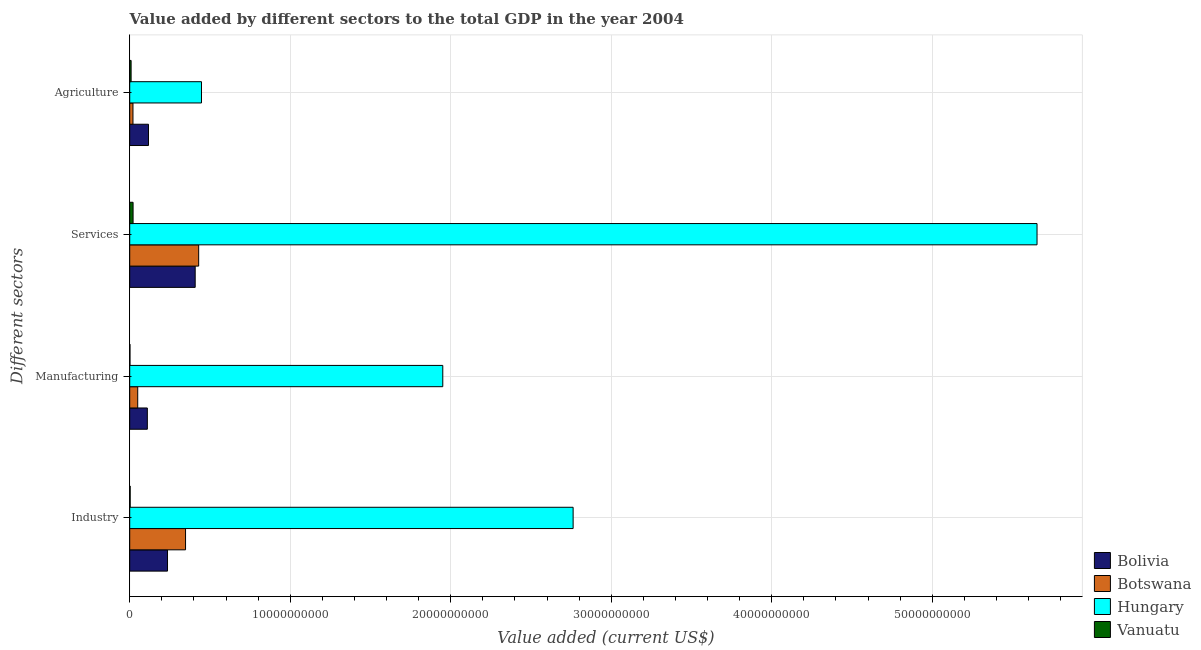How many bars are there on the 1st tick from the bottom?
Give a very brief answer. 4. What is the label of the 4th group of bars from the top?
Make the answer very short. Industry. What is the value added by services sector in Botswana?
Offer a very short reply. 4.30e+09. Across all countries, what is the maximum value added by industrial sector?
Offer a very short reply. 2.76e+1. Across all countries, what is the minimum value added by industrial sector?
Keep it short and to the point. 2.77e+07. In which country was the value added by manufacturing sector maximum?
Make the answer very short. Hungary. In which country was the value added by manufacturing sector minimum?
Offer a terse response. Vanuatu. What is the total value added by services sector in the graph?
Offer a very short reply. 6.51e+1. What is the difference between the value added by industrial sector in Botswana and that in Bolivia?
Give a very brief answer. 1.12e+09. What is the difference between the value added by manufacturing sector in Vanuatu and the value added by services sector in Botswana?
Give a very brief answer. -4.28e+09. What is the average value added by agricultural sector per country?
Your answer should be compact. 1.48e+09. What is the difference between the value added by agricultural sector and value added by services sector in Bolivia?
Your response must be concise. -2.91e+09. What is the ratio of the value added by agricultural sector in Hungary to that in Vanuatu?
Offer a very short reply. 51.9. Is the difference between the value added by agricultural sector in Hungary and Bolivia greater than the difference between the value added by industrial sector in Hungary and Bolivia?
Keep it short and to the point. No. What is the difference between the highest and the second highest value added by industrial sector?
Keep it short and to the point. 2.41e+1. What is the difference between the highest and the lowest value added by agricultural sector?
Provide a succinct answer. 4.38e+09. Is it the case that in every country, the sum of the value added by services sector and value added by agricultural sector is greater than the sum of value added by industrial sector and value added by manufacturing sector?
Provide a succinct answer. No. What does the 1st bar from the top in Industry represents?
Ensure brevity in your answer.  Vanuatu. What does the 4th bar from the bottom in Services represents?
Provide a short and direct response. Vanuatu. Are all the bars in the graph horizontal?
Provide a short and direct response. Yes. Are the values on the major ticks of X-axis written in scientific E-notation?
Your answer should be compact. No. Does the graph contain any zero values?
Your answer should be compact. No. Does the graph contain grids?
Offer a very short reply. Yes. How are the legend labels stacked?
Offer a very short reply. Vertical. What is the title of the graph?
Ensure brevity in your answer.  Value added by different sectors to the total GDP in the year 2004. What is the label or title of the X-axis?
Provide a short and direct response. Value added (current US$). What is the label or title of the Y-axis?
Offer a very short reply. Different sectors. What is the Value added (current US$) in Bolivia in Industry?
Your answer should be compact. 2.35e+09. What is the Value added (current US$) of Botswana in Industry?
Provide a succinct answer. 3.48e+09. What is the Value added (current US$) in Hungary in Industry?
Keep it short and to the point. 2.76e+1. What is the Value added (current US$) of Vanuatu in Industry?
Provide a succinct answer. 2.77e+07. What is the Value added (current US$) in Bolivia in Manufacturing?
Ensure brevity in your answer.  1.10e+09. What is the Value added (current US$) in Botswana in Manufacturing?
Give a very brief answer. 4.98e+08. What is the Value added (current US$) in Hungary in Manufacturing?
Keep it short and to the point. 1.95e+1. What is the Value added (current US$) of Vanuatu in Manufacturing?
Give a very brief answer. 1.47e+07. What is the Value added (current US$) of Bolivia in Services?
Provide a short and direct response. 4.08e+09. What is the Value added (current US$) in Botswana in Services?
Your answer should be very brief. 4.30e+09. What is the Value added (current US$) in Hungary in Services?
Provide a short and direct response. 5.65e+1. What is the Value added (current US$) of Vanuatu in Services?
Offer a terse response. 2.09e+08. What is the Value added (current US$) in Bolivia in Agriculture?
Give a very brief answer. 1.17e+09. What is the Value added (current US$) of Botswana in Agriculture?
Keep it short and to the point. 2.02e+08. What is the Value added (current US$) in Hungary in Agriculture?
Provide a short and direct response. 4.47e+09. What is the Value added (current US$) of Vanuatu in Agriculture?
Provide a succinct answer. 8.61e+07. Across all Different sectors, what is the maximum Value added (current US$) in Bolivia?
Your answer should be compact. 4.08e+09. Across all Different sectors, what is the maximum Value added (current US$) of Botswana?
Offer a very short reply. 4.30e+09. Across all Different sectors, what is the maximum Value added (current US$) of Hungary?
Provide a succinct answer. 5.65e+1. Across all Different sectors, what is the maximum Value added (current US$) in Vanuatu?
Provide a short and direct response. 2.09e+08. Across all Different sectors, what is the minimum Value added (current US$) in Bolivia?
Offer a terse response. 1.10e+09. Across all Different sectors, what is the minimum Value added (current US$) in Botswana?
Provide a succinct answer. 2.02e+08. Across all Different sectors, what is the minimum Value added (current US$) in Hungary?
Provide a succinct answer. 4.47e+09. Across all Different sectors, what is the minimum Value added (current US$) in Vanuatu?
Give a very brief answer. 1.47e+07. What is the total Value added (current US$) in Bolivia in the graph?
Make the answer very short. 8.70e+09. What is the total Value added (current US$) of Botswana in the graph?
Ensure brevity in your answer.  8.47e+09. What is the total Value added (current US$) of Hungary in the graph?
Provide a succinct answer. 1.08e+11. What is the total Value added (current US$) of Vanuatu in the graph?
Keep it short and to the point. 3.38e+08. What is the difference between the Value added (current US$) of Bolivia in Industry and that in Manufacturing?
Provide a short and direct response. 1.26e+09. What is the difference between the Value added (current US$) of Botswana in Industry and that in Manufacturing?
Provide a succinct answer. 2.98e+09. What is the difference between the Value added (current US$) of Hungary in Industry and that in Manufacturing?
Offer a very short reply. 8.12e+09. What is the difference between the Value added (current US$) of Vanuatu in Industry and that in Manufacturing?
Offer a very short reply. 1.30e+07. What is the difference between the Value added (current US$) of Bolivia in Industry and that in Services?
Your response must be concise. -1.72e+09. What is the difference between the Value added (current US$) in Botswana in Industry and that in Services?
Provide a short and direct response. -8.18e+08. What is the difference between the Value added (current US$) of Hungary in Industry and that in Services?
Provide a succinct answer. -2.89e+1. What is the difference between the Value added (current US$) in Vanuatu in Industry and that in Services?
Give a very brief answer. -1.82e+08. What is the difference between the Value added (current US$) of Bolivia in Industry and that in Agriculture?
Offer a terse response. 1.19e+09. What is the difference between the Value added (current US$) in Botswana in Industry and that in Agriculture?
Give a very brief answer. 3.28e+09. What is the difference between the Value added (current US$) in Hungary in Industry and that in Agriculture?
Keep it short and to the point. 2.32e+1. What is the difference between the Value added (current US$) of Vanuatu in Industry and that in Agriculture?
Ensure brevity in your answer.  -5.84e+07. What is the difference between the Value added (current US$) in Bolivia in Manufacturing and that in Services?
Give a very brief answer. -2.98e+09. What is the difference between the Value added (current US$) of Botswana in Manufacturing and that in Services?
Offer a terse response. -3.80e+09. What is the difference between the Value added (current US$) of Hungary in Manufacturing and that in Services?
Make the answer very short. -3.70e+1. What is the difference between the Value added (current US$) in Vanuatu in Manufacturing and that in Services?
Your answer should be compact. -1.95e+08. What is the difference between the Value added (current US$) in Bolivia in Manufacturing and that in Agriculture?
Provide a short and direct response. -7.15e+07. What is the difference between the Value added (current US$) of Botswana in Manufacturing and that in Agriculture?
Your response must be concise. 2.95e+08. What is the difference between the Value added (current US$) in Hungary in Manufacturing and that in Agriculture?
Offer a terse response. 1.50e+1. What is the difference between the Value added (current US$) of Vanuatu in Manufacturing and that in Agriculture?
Your answer should be very brief. -7.14e+07. What is the difference between the Value added (current US$) in Bolivia in Services and that in Agriculture?
Your response must be concise. 2.91e+09. What is the difference between the Value added (current US$) of Botswana in Services and that in Agriculture?
Provide a short and direct response. 4.09e+09. What is the difference between the Value added (current US$) of Hungary in Services and that in Agriculture?
Your response must be concise. 5.21e+1. What is the difference between the Value added (current US$) of Vanuatu in Services and that in Agriculture?
Ensure brevity in your answer.  1.23e+08. What is the difference between the Value added (current US$) in Bolivia in Industry and the Value added (current US$) in Botswana in Manufacturing?
Your answer should be compact. 1.86e+09. What is the difference between the Value added (current US$) in Bolivia in Industry and the Value added (current US$) in Hungary in Manufacturing?
Make the answer very short. -1.71e+1. What is the difference between the Value added (current US$) in Bolivia in Industry and the Value added (current US$) in Vanuatu in Manufacturing?
Ensure brevity in your answer.  2.34e+09. What is the difference between the Value added (current US$) of Botswana in Industry and the Value added (current US$) of Hungary in Manufacturing?
Offer a very short reply. -1.60e+1. What is the difference between the Value added (current US$) in Botswana in Industry and the Value added (current US$) in Vanuatu in Manufacturing?
Ensure brevity in your answer.  3.46e+09. What is the difference between the Value added (current US$) of Hungary in Industry and the Value added (current US$) of Vanuatu in Manufacturing?
Your answer should be very brief. 2.76e+1. What is the difference between the Value added (current US$) in Bolivia in Industry and the Value added (current US$) in Botswana in Services?
Offer a very short reply. -1.94e+09. What is the difference between the Value added (current US$) of Bolivia in Industry and the Value added (current US$) of Hungary in Services?
Make the answer very short. -5.42e+1. What is the difference between the Value added (current US$) in Bolivia in Industry and the Value added (current US$) in Vanuatu in Services?
Your response must be concise. 2.15e+09. What is the difference between the Value added (current US$) in Botswana in Industry and the Value added (current US$) in Hungary in Services?
Your answer should be compact. -5.30e+1. What is the difference between the Value added (current US$) of Botswana in Industry and the Value added (current US$) of Vanuatu in Services?
Provide a succinct answer. 3.27e+09. What is the difference between the Value added (current US$) in Hungary in Industry and the Value added (current US$) in Vanuatu in Services?
Your answer should be very brief. 2.74e+1. What is the difference between the Value added (current US$) in Bolivia in Industry and the Value added (current US$) in Botswana in Agriculture?
Make the answer very short. 2.15e+09. What is the difference between the Value added (current US$) in Bolivia in Industry and the Value added (current US$) in Hungary in Agriculture?
Give a very brief answer. -2.12e+09. What is the difference between the Value added (current US$) in Bolivia in Industry and the Value added (current US$) in Vanuatu in Agriculture?
Give a very brief answer. 2.27e+09. What is the difference between the Value added (current US$) of Botswana in Industry and the Value added (current US$) of Hungary in Agriculture?
Provide a succinct answer. -9.93e+08. What is the difference between the Value added (current US$) of Botswana in Industry and the Value added (current US$) of Vanuatu in Agriculture?
Provide a short and direct response. 3.39e+09. What is the difference between the Value added (current US$) of Hungary in Industry and the Value added (current US$) of Vanuatu in Agriculture?
Ensure brevity in your answer.  2.75e+1. What is the difference between the Value added (current US$) in Bolivia in Manufacturing and the Value added (current US$) in Botswana in Services?
Make the answer very short. -3.20e+09. What is the difference between the Value added (current US$) of Bolivia in Manufacturing and the Value added (current US$) of Hungary in Services?
Make the answer very short. -5.54e+1. What is the difference between the Value added (current US$) of Bolivia in Manufacturing and the Value added (current US$) of Vanuatu in Services?
Give a very brief answer. 8.88e+08. What is the difference between the Value added (current US$) of Botswana in Manufacturing and the Value added (current US$) of Hungary in Services?
Make the answer very short. -5.60e+1. What is the difference between the Value added (current US$) of Botswana in Manufacturing and the Value added (current US$) of Vanuatu in Services?
Your answer should be compact. 2.88e+08. What is the difference between the Value added (current US$) in Hungary in Manufacturing and the Value added (current US$) in Vanuatu in Services?
Your answer should be compact. 1.93e+1. What is the difference between the Value added (current US$) of Bolivia in Manufacturing and the Value added (current US$) of Botswana in Agriculture?
Give a very brief answer. 8.95e+08. What is the difference between the Value added (current US$) of Bolivia in Manufacturing and the Value added (current US$) of Hungary in Agriculture?
Make the answer very short. -3.37e+09. What is the difference between the Value added (current US$) in Bolivia in Manufacturing and the Value added (current US$) in Vanuatu in Agriculture?
Make the answer very short. 1.01e+09. What is the difference between the Value added (current US$) in Botswana in Manufacturing and the Value added (current US$) in Hungary in Agriculture?
Give a very brief answer. -3.97e+09. What is the difference between the Value added (current US$) in Botswana in Manufacturing and the Value added (current US$) in Vanuatu in Agriculture?
Offer a terse response. 4.11e+08. What is the difference between the Value added (current US$) of Hungary in Manufacturing and the Value added (current US$) of Vanuatu in Agriculture?
Provide a succinct answer. 1.94e+1. What is the difference between the Value added (current US$) in Bolivia in Services and the Value added (current US$) in Botswana in Agriculture?
Your answer should be very brief. 3.88e+09. What is the difference between the Value added (current US$) in Bolivia in Services and the Value added (current US$) in Hungary in Agriculture?
Your response must be concise. -3.92e+08. What is the difference between the Value added (current US$) of Bolivia in Services and the Value added (current US$) of Vanuatu in Agriculture?
Your response must be concise. 3.99e+09. What is the difference between the Value added (current US$) in Botswana in Services and the Value added (current US$) in Hungary in Agriculture?
Offer a very short reply. -1.75e+08. What is the difference between the Value added (current US$) in Botswana in Services and the Value added (current US$) in Vanuatu in Agriculture?
Provide a short and direct response. 4.21e+09. What is the difference between the Value added (current US$) of Hungary in Services and the Value added (current US$) of Vanuatu in Agriculture?
Your response must be concise. 5.64e+1. What is the average Value added (current US$) in Bolivia per Different sectors?
Keep it short and to the point. 2.17e+09. What is the average Value added (current US$) of Botswana per Different sectors?
Your response must be concise. 2.12e+09. What is the average Value added (current US$) in Hungary per Different sectors?
Offer a terse response. 2.70e+1. What is the average Value added (current US$) of Vanuatu per Different sectors?
Offer a terse response. 8.45e+07. What is the difference between the Value added (current US$) in Bolivia and Value added (current US$) in Botswana in Industry?
Your response must be concise. -1.12e+09. What is the difference between the Value added (current US$) in Bolivia and Value added (current US$) in Hungary in Industry?
Provide a succinct answer. -2.53e+1. What is the difference between the Value added (current US$) of Bolivia and Value added (current US$) of Vanuatu in Industry?
Provide a succinct answer. 2.33e+09. What is the difference between the Value added (current US$) in Botswana and Value added (current US$) in Hungary in Industry?
Make the answer very short. -2.41e+1. What is the difference between the Value added (current US$) of Botswana and Value added (current US$) of Vanuatu in Industry?
Ensure brevity in your answer.  3.45e+09. What is the difference between the Value added (current US$) in Hungary and Value added (current US$) in Vanuatu in Industry?
Your response must be concise. 2.76e+1. What is the difference between the Value added (current US$) in Bolivia and Value added (current US$) in Botswana in Manufacturing?
Your answer should be compact. 6.00e+08. What is the difference between the Value added (current US$) in Bolivia and Value added (current US$) in Hungary in Manufacturing?
Provide a succinct answer. -1.84e+1. What is the difference between the Value added (current US$) in Bolivia and Value added (current US$) in Vanuatu in Manufacturing?
Keep it short and to the point. 1.08e+09. What is the difference between the Value added (current US$) of Botswana and Value added (current US$) of Hungary in Manufacturing?
Your answer should be very brief. -1.90e+1. What is the difference between the Value added (current US$) of Botswana and Value added (current US$) of Vanuatu in Manufacturing?
Your answer should be very brief. 4.83e+08. What is the difference between the Value added (current US$) in Hungary and Value added (current US$) in Vanuatu in Manufacturing?
Provide a succinct answer. 1.95e+1. What is the difference between the Value added (current US$) of Bolivia and Value added (current US$) of Botswana in Services?
Your response must be concise. -2.17e+08. What is the difference between the Value added (current US$) of Bolivia and Value added (current US$) of Hungary in Services?
Your answer should be compact. -5.24e+1. What is the difference between the Value added (current US$) of Bolivia and Value added (current US$) of Vanuatu in Services?
Offer a very short reply. 3.87e+09. What is the difference between the Value added (current US$) in Botswana and Value added (current US$) in Hungary in Services?
Ensure brevity in your answer.  -5.22e+1. What is the difference between the Value added (current US$) in Botswana and Value added (current US$) in Vanuatu in Services?
Ensure brevity in your answer.  4.09e+09. What is the difference between the Value added (current US$) in Hungary and Value added (current US$) in Vanuatu in Services?
Your response must be concise. 5.63e+1. What is the difference between the Value added (current US$) in Bolivia and Value added (current US$) in Botswana in Agriculture?
Make the answer very short. 9.66e+08. What is the difference between the Value added (current US$) in Bolivia and Value added (current US$) in Hungary in Agriculture?
Your answer should be compact. -3.30e+09. What is the difference between the Value added (current US$) of Bolivia and Value added (current US$) of Vanuatu in Agriculture?
Keep it short and to the point. 1.08e+09. What is the difference between the Value added (current US$) of Botswana and Value added (current US$) of Hungary in Agriculture?
Provide a succinct answer. -4.27e+09. What is the difference between the Value added (current US$) of Botswana and Value added (current US$) of Vanuatu in Agriculture?
Provide a short and direct response. 1.16e+08. What is the difference between the Value added (current US$) of Hungary and Value added (current US$) of Vanuatu in Agriculture?
Give a very brief answer. 4.38e+09. What is the ratio of the Value added (current US$) of Bolivia in Industry to that in Manufacturing?
Offer a very short reply. 2.15. What is the ratio of the Value added (current US$) of Botswana in Industry to that in Manufacturing?
Offer a terse response. 6.99. What is the ratio of the Value added (current US$) in Hungary in Industry to that in Manufacturing?
Your answer should be compact. 1.42. What is the ratio of the Value added (current US$) in Vanuatu in Industry to that in Manufacturing?
Ensure brevity in your answer.  1.88. What is the ratio of the Value added (current US$) in Bolivia in Industry to that in Services?
Your response must be concise. 0.58. What is the ratio of the Value added (current US$) of Botswana in Industry to that in Services?
Ensure brevity in your answer.  0.81. What is the ratio of the Value added (current US$) of Hungary in Industry to that in Services?
Provide a succinct answer. 0.49. What is the ratio of the Value added (current US$) of Vanuatu in Industry to that in Services?
Provide a succinct answer. 0.13. What is the ratio of the Value added (current US$) in Bolivia in Industry to that in Agriculture?
Offer a very short reply. 2.01. What is the ratio of the Value added (current US$) in Botswana in Industry to that in Agriculture?
Make the answer very short. 17.18. What is the ratio of the Value added (current US$) in Hungary in Industry to that in Agriculture?
Keep it short and to the point. 6.18. What is the ratio of the Value added (current US$) of Vanuatu in Industry to that in Agriculture?
Offer a very short reply. 0.32. What is the ratio of the Value added (current US$) in Bolivia in Manufacturing to that in Services?
Offer a very short reply. 0.27. What is the ratio of the Value added (current US$) in Botswana in Manufacturing to that in Services?
Provide a succinct answer. 0.12. What is the ratio of the Value added (current US$) in Hungary in Manufacturing to that in Services?
Offer a terse response. 0.34. What is the ratio of the Value added (current US$) in Vanuatu in Manufacturing to that in Services?
Provide a succinct answer. 0.07. What is the ratio of the Value added (current US$) in Bolivia in Manufacturing to that in Agriculture?
Ensure brevity in your answer.  0.94. What is the ratio of the Value added (current US$) of Botswana in Manufacturing to that in Agriculture?
Your answer should be very brief. 2.46. What is the ratio of the Value added (current US$) of Hungary in Manufacturing to that in Agriculture?
Provide a succinct answer. 4.36. What is the ratio of the Value added (current US$) in Vanuatu in Manufacturing to that in Agriculture?
Provide a short and direct response. 0.17. What is the ratio of the Value added (current US$) in Bolivia in Services to that in Agriculture?
Offer a terse response. 3.49. What is the ratio of the Value added (current US$) of Botswana in Services to that in Agriculture?
Your answer should be very brief. 21.22. What is the ratio of the Value added (current US$) in Hungary in Services to that in Agriculture?
Provide a succinct answer. 12.64. What is the ratio of the Value added (current US$) of Vanuatu in Services to that in Agriculture?
Your answer should be compact. 2.43. What is the difference between the highest and the second highest Value added (current US$) of Bolivia?
Your response must be concise. 1.72e+09. What is the difference between the highest and the second highest Value added (current US$) of Botswana?
Provide a succinct answer. 8.18e+08. What is the difference between the highest and the second highest Value added (current US$) of Hungary?
Keep it short and to the point. 2.89e+1. What is the difference between the highest and the second highest Value added (current US$) in Vanuatu?
Ensure brevity in your answer.  1.23e+08. What is the difference between the highest and the lowest Value added (current US$) in Bolivia?
Your answer should be very brief. 2.98e+09. What is the difference between the highest and the lowest Value added (current US$) in Botswana?
Your answer should be very brief. 4.09e+09. What is the difference between the highest and the lowest Value added (current US$) of Hungary?
Make the answer very short. 5.21e+1. What is the difference between the highest and the lowest Value added (current US$) of Vanuatu?
Make the answer very short. 1.95e+08. 